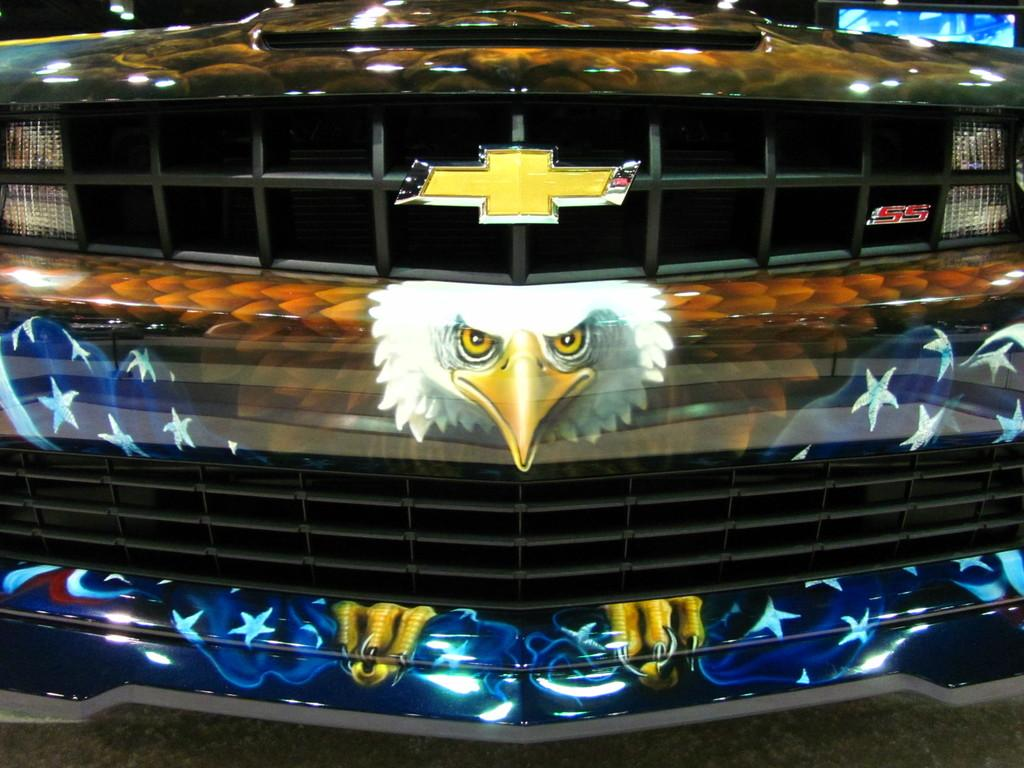What is the main subject of the image? There is a vehicle in the image. What design element is present on the vehicle? The vehicle has a design of an animal. Is there any text or symbol visible on the vehicle? Yes, there is a logo visible in the image. How many oranges are being used to create the wave in the image? There are no oranges or waves present in the image; it features a vehicle with an animal design and a logo. 